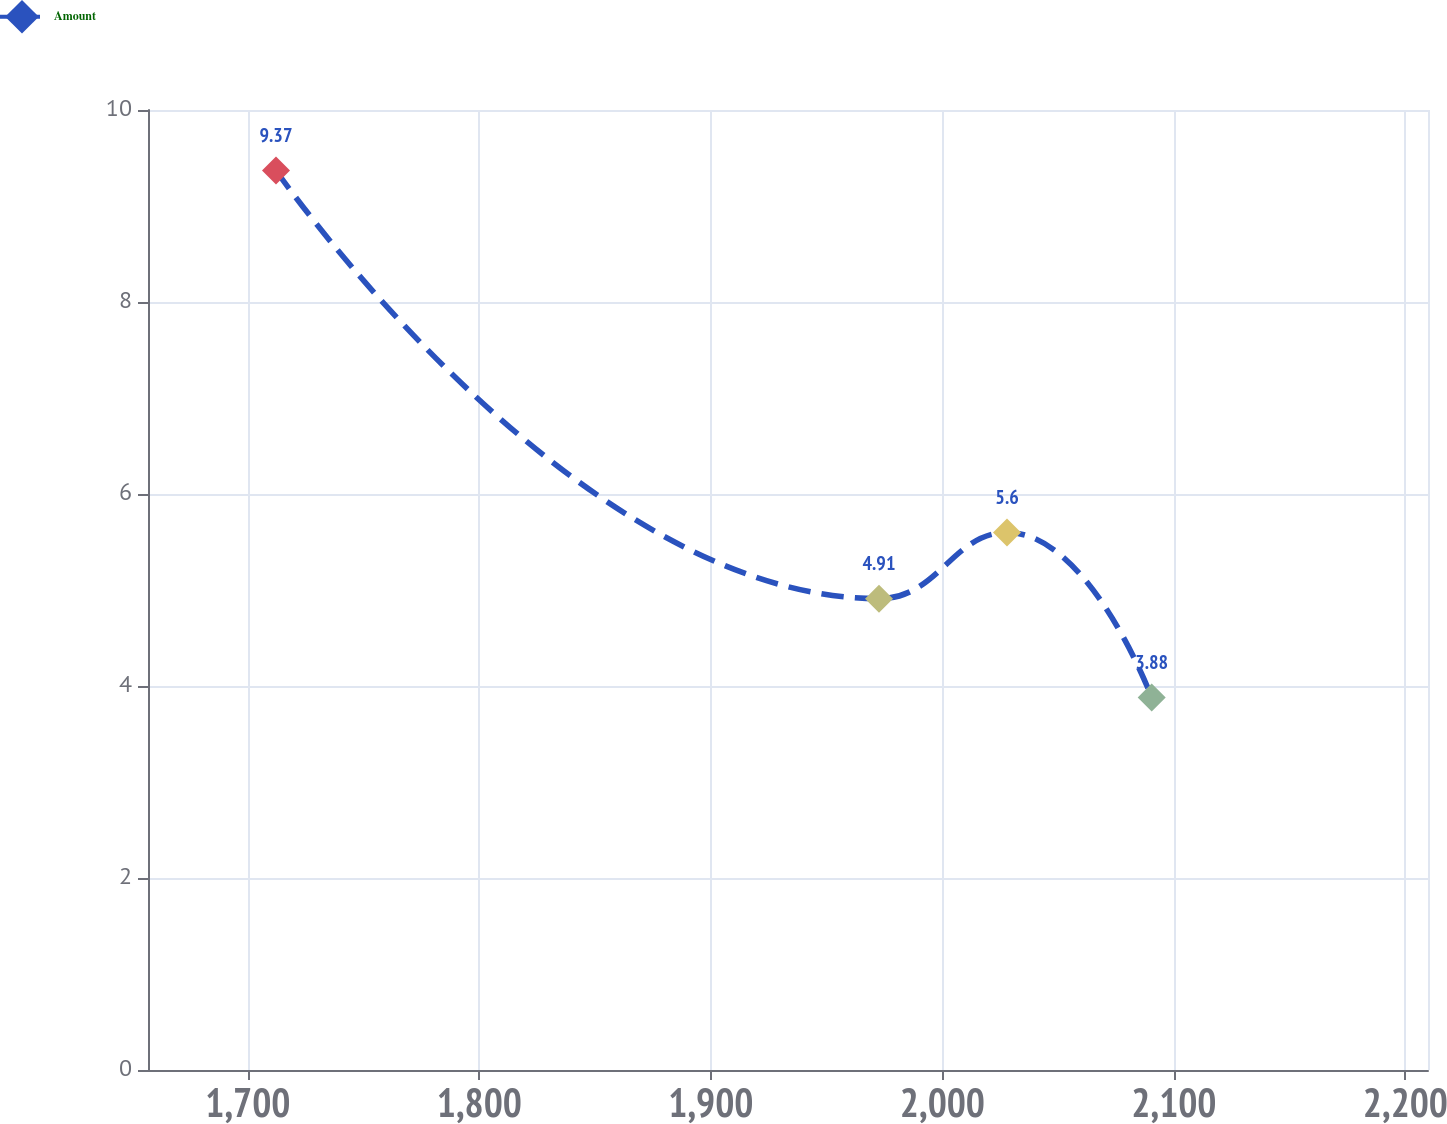Convert chart. <chart><loc_0><loc_0><loc_500><loc_500><line_chart><ecel><fcel>Amount<nl><fcel>1712.13<fcel>9.37<nl><fcel>1972.61<fcel>4.91<nl><fcel>2027.9<fcel>5.6<nl><fcel>2090.4<fcel>3.88<nl><fcel>2265.04<fcel>2.47<nl></chart> 